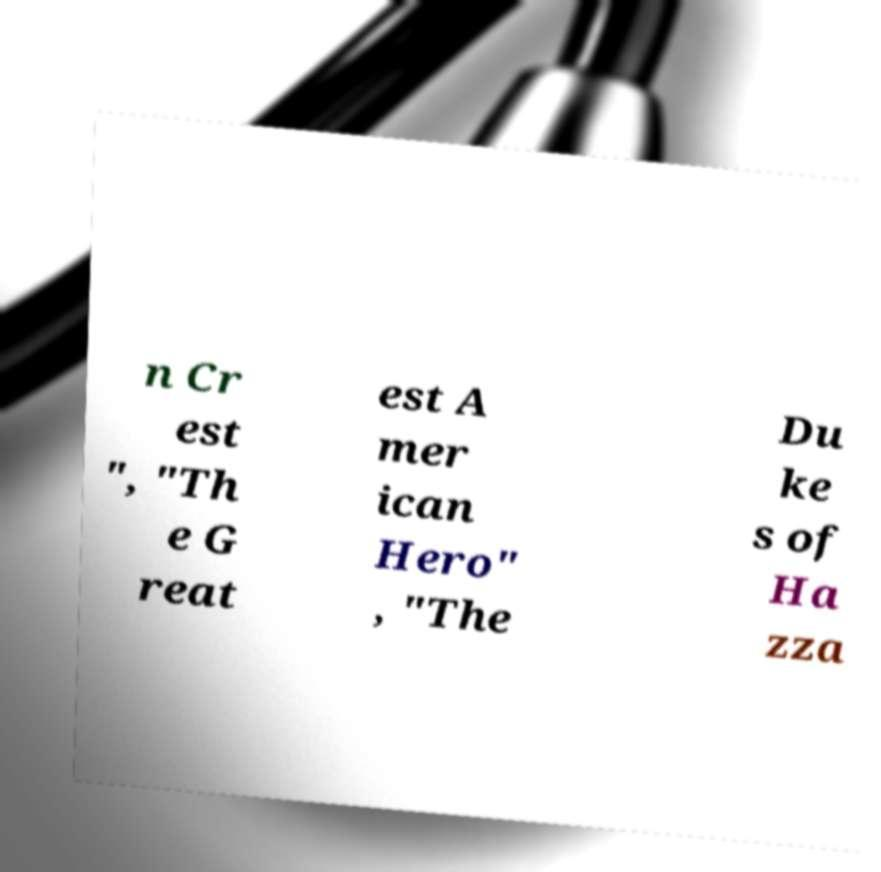What messages or text are displayed in this image? I need them in a readable, typed format. n Cr est ", "Th e G reat est A mer ican Hero" , "The Du ke s of Ha zza 